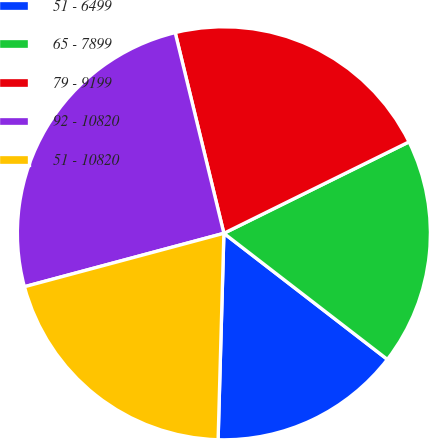Convert chart. <chart><loc_0><loc_0><loc_500><loc_500><pie_chart><fcel>51 - 6499<fcel>65 - 7899<fcel>79 - 9199<fcel>92 - 10820<fcel>51 - 10820<nl><fcel>14.99%<fcel>17.76%<fcel>21.49%<fcel>25.38%<fcel>20.39%<nl></chart> 